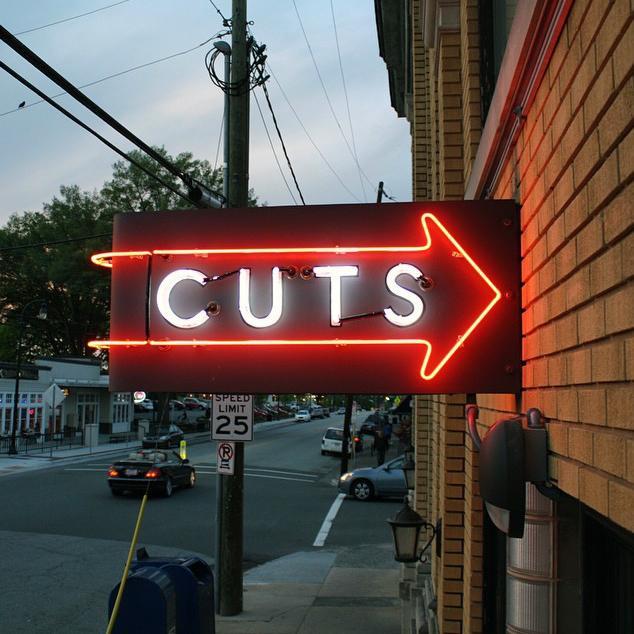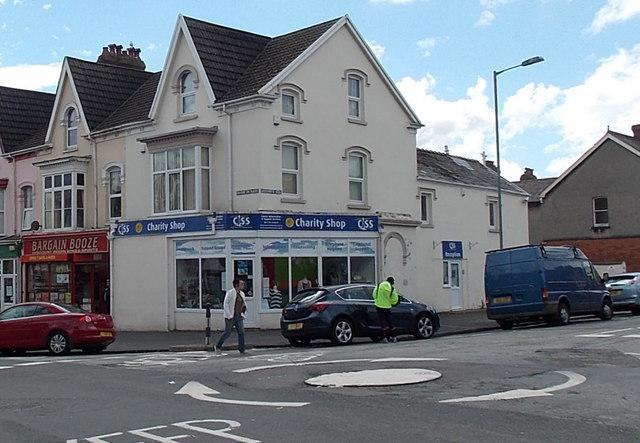The first image is the image on the left, the second image is the image on the right. Considering the images on both sides, is "There is at least one barber pole in the image on the right" valid? Answer yes or no. No. The first image is the image on the left, the second image is the image on the right. Examine the images to the left and right. Is the description "A truck is visible in one image, and at least one car is visible in each image." accurate? Answer yes or no. Yes. 